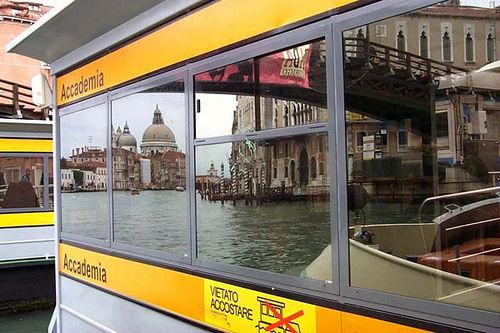Are there windows?
Short answer required. Yes. What language is the sign in?
Give a very brief answer. Italian. Is that a mirror or a window?
Concise answer only. Window. 